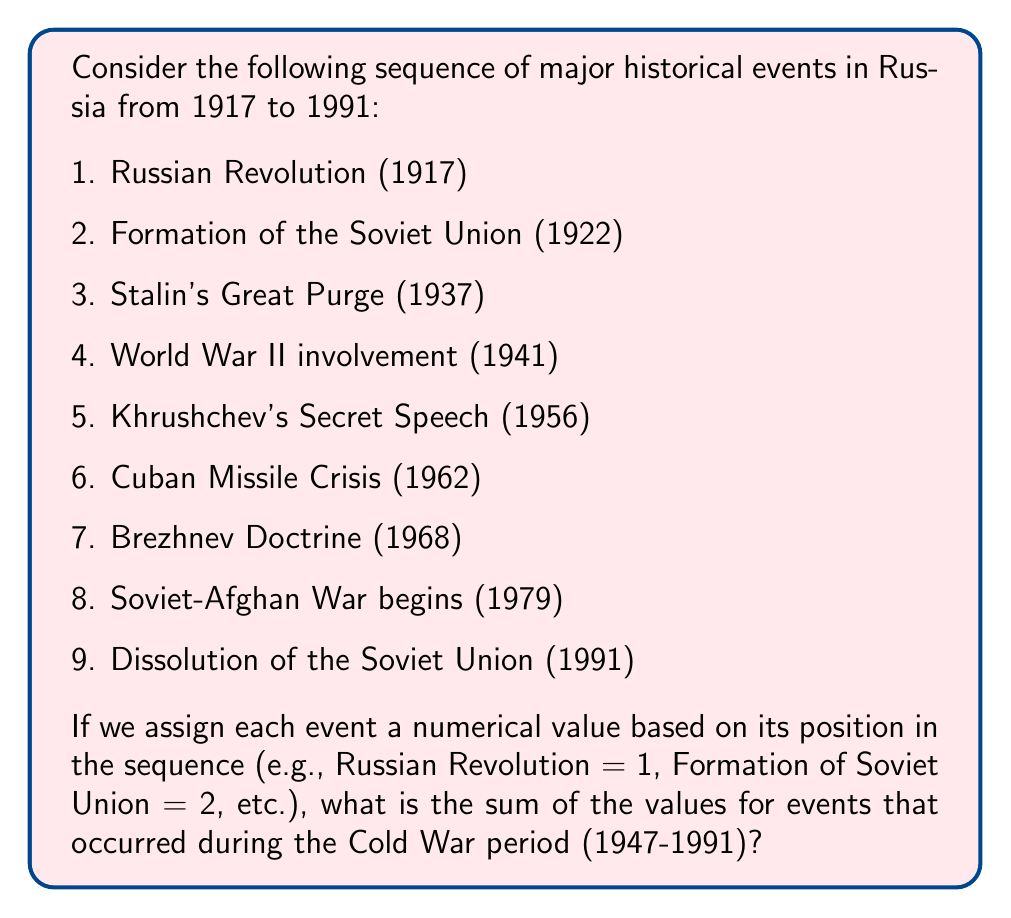Help me with this question. To solve this problem, we need to follow these steps:

1. Identify the events that occurred during the Cold War period (1947-1991):
   - Khrushchev's Secret Speech (1956)
   - Cuban Missile Crisis (1962)
   - Brezhnev Doctrine (1968)
   - Soviet-Afghan War begins (1979)
   - Dissolution of the Soviet Union (1991)

2. Assign the corresponding numerical values to these events:
   - Khrushchev's Secret Speech: 5
   - Cuban Missile Crisis: 6
   - Brezhnev Doctrine: 7
   - Soviet-Afghan War begins: 8
   - Dissolution of the Soviet Union: 9

3. Sum up the numerical values:

   $$5 + 6 + 7 + 8 + 9 = 35$$

Therefore, the sum of the values for events that occurred during the Cold War period is 35.
Answer: 35 